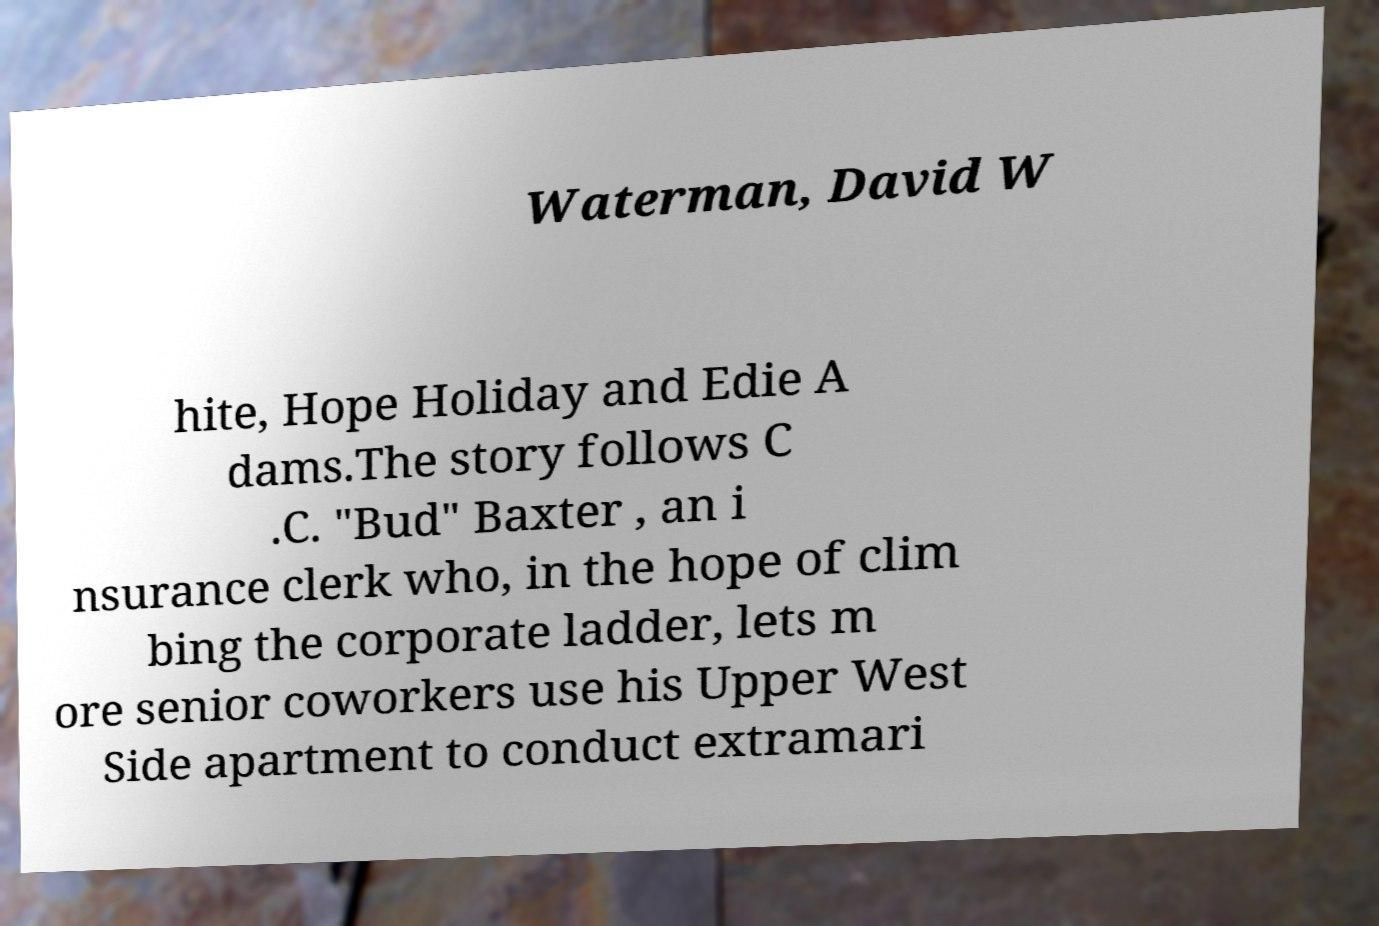Please identify and transcribe the text found in this image. Waterman, David W hite, Hope Holiday and Edie A dams.The story follows C .C. "Bud" Baxter , an i nsurance clerk who, in the hope of clim bing the corporate ladder, lets m ore senior coworkers use his Upper West Side apartment to conduct extramari 